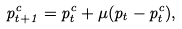<formula> <loc_0><loc_0><loc_500><loc_500>p ^ { c } _ { t + 1 } = p ^ { c } _ { t } + \mu ( p _ { t } - p ^ { c } _ { t } ) ,</formula> 